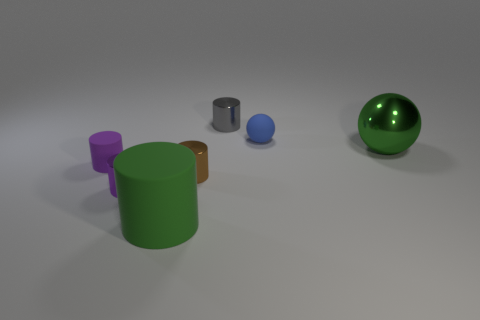There is a rubber object that is the same color as the large metallic ball; what size is it?
Give a very brief answer. Large. How many cylinders are either blue shiny things or large matte things?
Provide a succinct answer. 1. The object behind the tiny blue ball is what color?
Offer a very short reply. Gray. What is the shape of the shiny thing that is the same color as the large rubber thing?
Keep it short and to the point. Sphere. What number of green metallic things have the same size as the green matte thing?
Your answer should be very brief. 1. Do the large object right of the green cylinder and the small purple rubber object to the left of the large green cylinder have the same shape?
Your answer should be compact. No. There is a large object behind the big thing that is left of the large thing that is to the right of the tiny gray object; what is it made of?
Offer a very short reply. Metal. What shape is the blue matte object that is the same size as the brown object?
Provide a succinct answer. Sphere. Are there any tiny metal cylinders that have the same color as the big sphere?
Offer a terse response. No. What is the size of the purple metal cylinder?
Your answer should be compact. Small. 